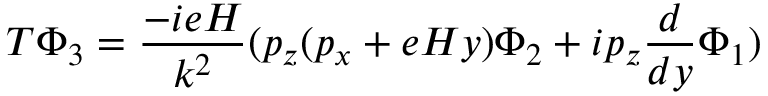<formula> <loc_0><loc_0><loc_500><loc_500>T \Phi _ { 3 } = \frac { - i e H } { k ^ { 2 } } ( p _ { z } ( p _ { x } + e H y ) \Phi _ { 2 } + i p _ { z } \frac { d } { d y } \Phi _ { 1 } )</formula> 